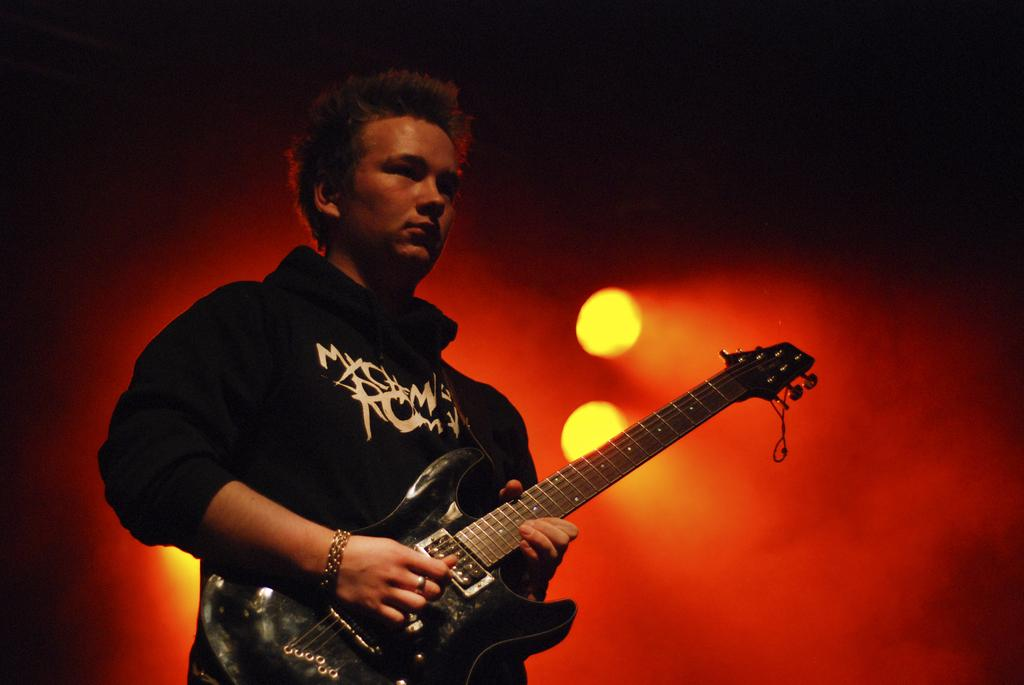Who is the main subject in the image? There is a man in the image. What is the man wearing? The man is wearing a black jacket. What is the man holding in the image? The man is holding a guitar. What can be seen behind the man in the image? There is a red light emitting behind the man. What type of glass is the man drinking from in the image? There is no glass present in the image; the man is holding a guitar. 